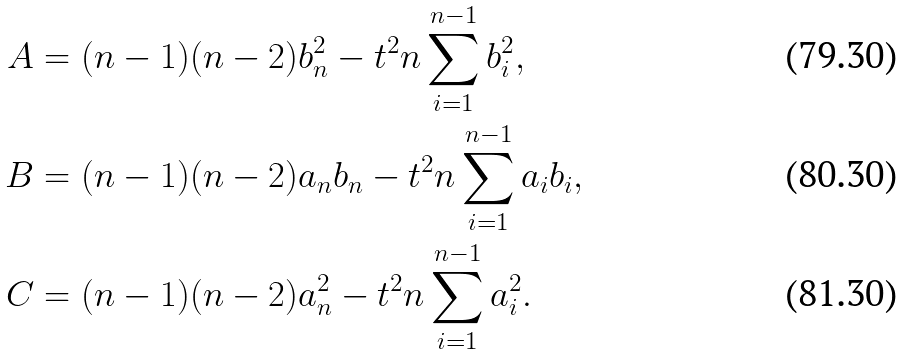Convert formula to latex. <formula><loc_0><loc_0><loc_500><loc_500>A & = ( n - 1 ) ( n - 2 ) b _ { n } ^ { 2 } - t ^ { 2 } n \sum _ { i = 1 } ^ { n - 1 } b _ { i } ^ { 2 } , \\ B & = ( n - 1 ) ( n - 2 ) a _ { n } b _ { n } - t ^ { 2 } n \sum _ { i = 1 } ^ { n - 1 } a _ { i } b _ { i } , \\ C & = ( n - 1 ) ( n - 2 ) a _ { n } ^ { 2 } - t ^ { 2 } n \sum _ { i = 1 } ^ { n - 1 } a _ { i } ^ { 2 } .</formula> 